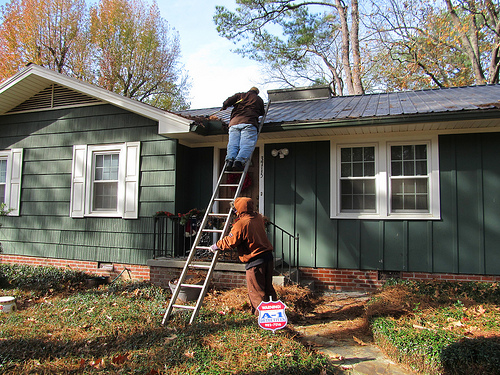<image>
Is the man above the ground? Yes. The man is positioned above the ground in the vertical space, higher up in the scene. Is the ladder on the door? No. The ladder is not positioned on the door. They may be near each other, but the ladder is not supported by or resting on top of the door. 